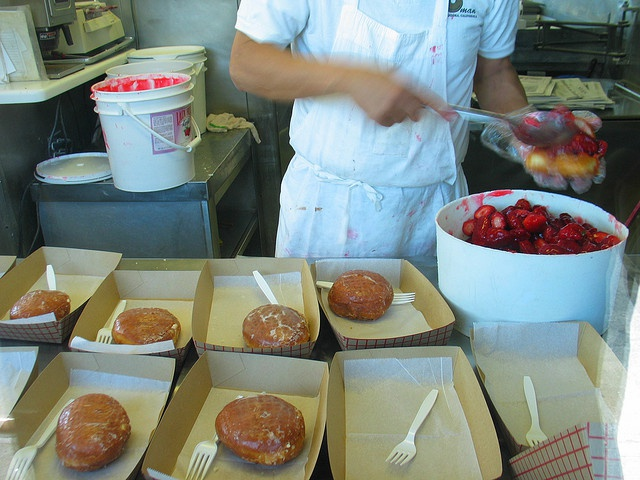Describe the objects in this image and their specific colors. I can see people in darkgreen, lightblue, tan, and gray tones, donut in darkgreen, brown, maroon, and gray tones, donut in darkgreen, brown, gray, and maroon tones, fork in darkgreen, darkgray, lightgray, and beige tones, and donut in darkgreen, brown, maroon, and gray tones in this image. 